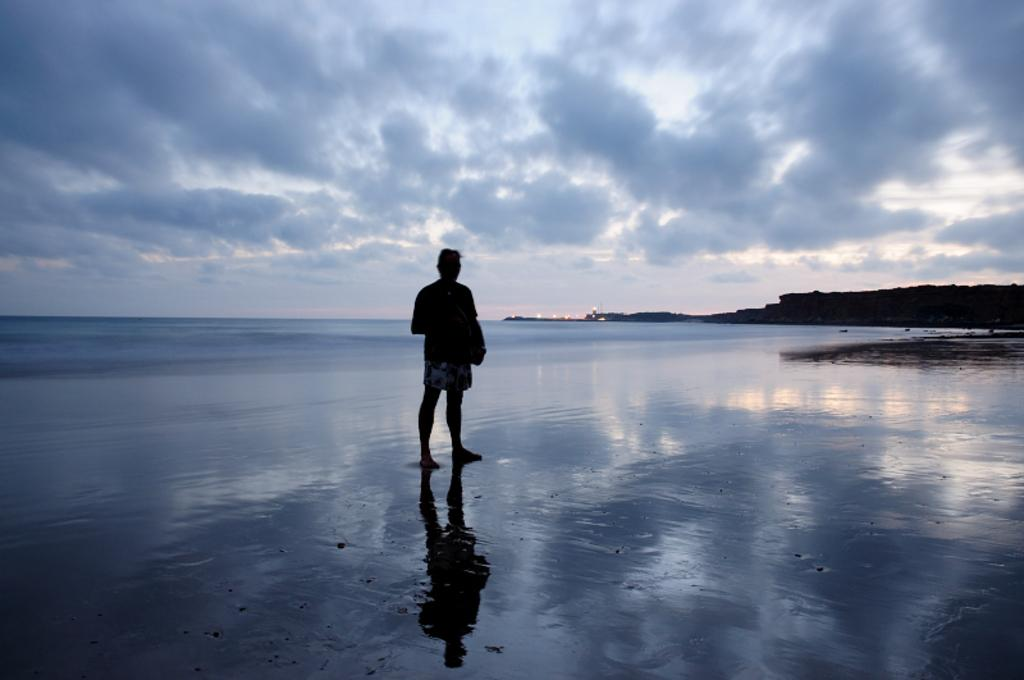What is the main subject of the image? There is a person standing in the image. What can be seen in the background of the image? Mountains and the sky are visible in the background of the image. What is the condition of the sky in the image? Clouds are present in the sky. What else is visible in the image besides the person and the sky? There is water and lights visible in the image. What type of guitar can be seen being played in the image? There is no guitar present in the image; it features a person standing near water, mountains, and lights. What observation can be made about the stream in the image? There is no stream present in the image; it features water, but not a stream. 